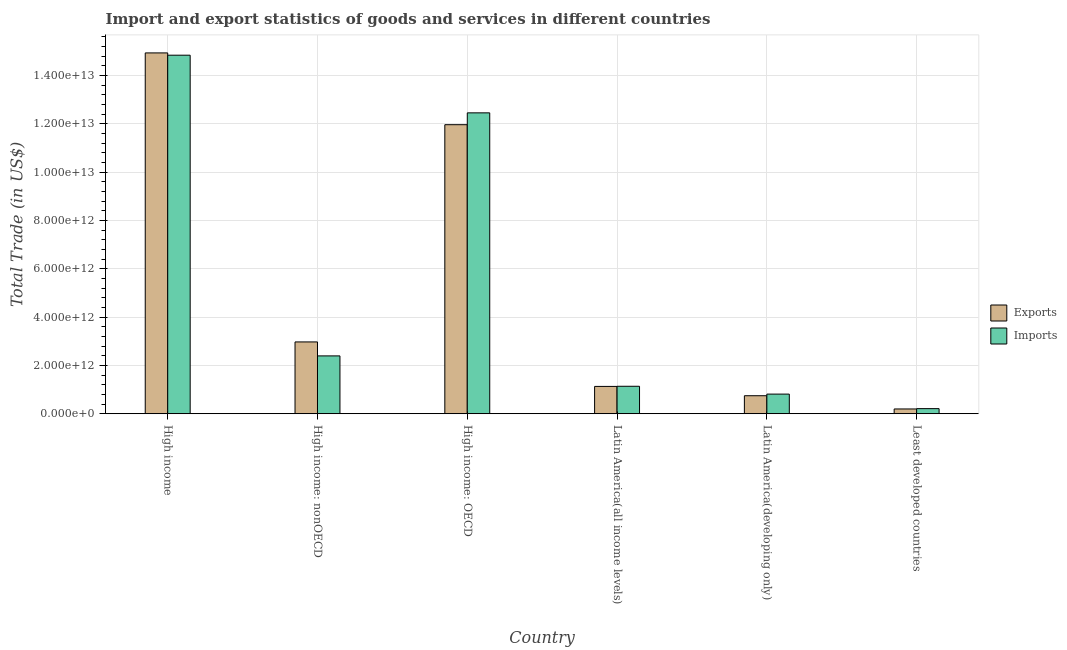How many different coloured bars are there?
Ensure brevity in your answer.  2. Are the number of bars on each tick of the X-axis equal?
Provide a short and direct response. Yes. What is the label of the 4th group of bars from the left?
Offer a terse response. Latin America(all income levels). What is the imports of goods and services in Least developed countries?
Ensure brevity in your answer.  2.12e+11. Across all countries, what is the maximum imports of goods and services?
Provide a short and direct response. 1.48e+13. Across all countries, what is the minimum imports of goods and services?
Keep it short and to the point. 2.12e+11. In which country was the export of goods and services maximum?
Ensure brevity in your answer.  High income. In which country was the imports of goods and services minimum?
Offer a terse response. Least developed countries. What is the total export of goods and services in the graph?
Your answer should be very brief. 3.20e+13. What is the difference between the imports of goods and services in High income: OECD and that in Least developed countries?
Your answer should be compact. 1.22e+13. What is the difference between the export of goods and services in Latin America(all income levels) and the imports of goods and services in Least developed countries?
Offer a very short reply. 9.20e+11. What is the average export of goods and services per country?
Ensure brevity in your answer.  5.33e+12. What is the difference between the imports of goods and services and export of goods and services in Latin America(developing only)?
Make the answer very short. 6.69e+1. In how many countries, is the export of goods and services greater than 6400000000000 US$?
Ensure brevity in your answer.  2. What is the ratio of the export of goods and services in Latin America(all income levels) to that in Least developed countries?
Ensure brevity in your answer.  5.73. Is the imports of goods and services in High income: nonOECD less than that in Latin America(all income levels)?
Ensure brevity in your answer.  No. What is the difference between the highest and the second highest export of goods and services?
Your response must be concise. 2.97e+12. What is the difference between the highest and the lowest imports of goods and services?
Offer a very short reply. 1.46e+13. Is the sum of the export of goods and services in High income and High income: OECD greater than the maximum imports of goods and services across all countries?
Give a very brief answer. Yes. What does the 1st bar from the left in High income represents?
Offer a very short reply. Exports. What does the 1st bar from the right in High income: nonOECD represents?
Ensure brevity in your answer.  Imports. Are all the bars in the graph horizontal?
Your response must be concise. No. How many countries are there in the graph?
Make the answer very short. 6. What is the difference between two consecutive major ticks on the Y-axis?
Offer a terse response. 2.00e+12. Are the values on the major ticks of Y-axis written in scientific E-notation?
Your answer should be very brief. Yes. Does the graph contain grids?
Keep it short and to the point. Yes. How many legend labels are there?
Your answer should be compact. 2. How are the legend labels stacked?
Ensure brevity in your answer.  Vertical. What is the title of the graph?
Offer a very short reply. Import and export statistics of goods and services in different countries. What is the label or title of the X-axis?
Your answer should be very brief. Country. What is the label or title of the Y-axis?
Ensure brevity in your answer.  Total Trade (in US$). What is the Total Trade (in US$) in Exports in High income?
Offer a terse response. 1.49e+13. What is the Total Trade (in US$) of Imports in High income?
Provide a short and direct response. 1.48e+13. What is the Total Trade (in US$) of Exports in High income: nonOECD?
Offer a terse response. 2.97e+12. What is the Total Trade (in US$) of Imports in High income: nonOECD?
Your answer should be compact. 2.39e+12. What is the Total Trade (in US$) of Exports in High income: OECD?
Your answer should be very brief. 1.20e+13. What is the Total Trade (in US$) in Imports in High income: OECD?
Offer a very short reply. 1.25e+13. What is the Total Trade (in US$) in Exports in Latin America(all income levels)?
Offer a very short reply. 1.13e+12. What is the Total Trade (in US$) in Imports in Latin America(all income levels)?
Your answer should be compact. 1.14e+12. What is the Total Trade (in US$) of Exports in Latin America(developing only)?
Ensure brevity in your answer.  7.46e+11. What is the Total Trade (in US$) in Imports in Latin America(developing only)?
Your answer should be compact. 8.13e+11. What is the Total Trade (in US$) in Exports in Least developed countries?
Your answer should be compact. 1.98e+11. What is the Total Trade (in US$) in Imports in Least developed countries?
Ensure brevity in your answer.  2.12e+11. Across all countries, what is the maximum Total Trade (in US$) in Exports?
Offer a terse response. 1.49e+13. Across all countries, what is the maximum Total Trade (in US$) in Imports?
Make the answer very short. 1.48e+13. Across all countries, what is the minimum Total Trade (in US$) in Exports?
Offer a terse response. 1.98e+11. Across all countries, what is the minimum Total Trade (in US$) in Imports?
Your answer should be compact. 2.12e+11. What is the total Total Trade (in US$) in Exports in the graph?
Keep it short and to the point. 3.20e+13. What is the total Total Trade (in US$) of Imports in the graph?
Ensure brevity in your answer.  3.19e+13. What is the difference between the Total Trade (in US$) in Exports in High income and that in High income: nonOECD?
Your answer should be compact. 1.20e+13. What is the difference between the Total Trade (in US$) of Imports in High income and that in High income: nonOECD?
Provide a succinct answer. 1.25e+13. What is the difference between the Total Trade (in US$) in Exports in High income and that in High income: OECD?
Ensure brevity in your answer.  2.97e+12. What is the difference between the Total Trade (in US$) in Imports in High income and that in High income: OECD?
Keep it short and to the point. 2.39e+12. What is the difference between the Total Trade (in US$) of Exports in High income and that in Latin America(all income levels)?
Give a very brief answer. 1.38e+13. What is the difference between the Total Trade (in US$) in Imports in High income and that in Latin America(all income levels)?
Offer a terse response. 1.37e+13. What is the difference between the Total Trade (in US$) in Exports in High income and that in Latin America(developing only)?
Offer a terse response. 1.42e+13. What is the difference between the Total Trade (in US$) in Imports in High income and that in Latin America(developing only)?
Your answer should be very brief. 1.40e+13. What is the difference between the Total Trade (in US$) of Exports in High income and that in Least developed countries?
Your answer should be very brief. 1.47e+13. What is the difference between the Total Trade (in US$) in Imports in High income and that in Least developed countries?
Offer a very short reply. 1.46e+13. What is the difference between the Total Trade (in US$) of Exports in High income: nonOECD and that in High income: OECD?
Provide a succinct answer. -9.00e+12. What is the difference between the Total Trade (in US$) of Imports in High income: nonOECD and that in High income: OECD?
Give a very brief answer. -1.01e+13. What is the difference between the Total Trade (in US$) of Exports in High income: nonOECD and that in Latin America(all income levels)?
Offer a terse response. 1.84e+12. What is the difference between the Total Trade (in US$) of Imports in High income: nonOECD and that in Latin America(all income levels)?
Your response must be concise. 1.26e+12. What is the difference between the Total Trade (in US$) in Exports in High income: nonOECD and that in Latin America(developing only)?
Ensure brevity in your answer.  2.23e+12. What is the difference between the Total Trade (in US$) in Imports in High income: nonOECD and that in Latin America(developing only)?
Your response must be concise. 1.58e+12. What is the difference between the Total Trade (in US$) of Exports in High income: nonOECD and that in Least developed countries?
Offer a very short reply. 2.78e+12. What is the difference between the Total Trade (in US$) in Imports in High income: nonOECD and that in Least developed countries?
Provide a short and direct response. 2.18e+12. What is the difference between the Total Trade (in US$) of Exports in High income: OECD and that in Latin America(all income levels)?
Give a very brief answer. 1.08e+13. What is the difference between the Total Trade (in US$) in Imports in High income: OECD and that in Latin America(all income levels)?
Provide a short and direct response. 1.13e+13. What is the difference between the Total Trade (in US$) in Exports in High income: OECD and that in Latin America(developing only)?
Make the answer very short. 1.12e+13. What is the difference between the Total Trade (in US$) in Imports in High income: OECD and that in Latin America(developing only)?
Offer a terse response. 1.16e+13. What is the difference between the Total Trade (in US$) in Exports in High income: OECD and that in Least developed countries?
Keep it short and to the point. 1.18e+13. What is the difference between the Total Trade (in US$) of Imports in High income: OECD and that in Least developed countries?
Offer a very short reply. 1.22e+13. What is the difference between the Total Trade (in US$) in Exports in Latin America(all income levels) and that in Latin America(developing only)?
Your answer should be very brief. 3.85e+11. What is the difference between the Total Trade (in US$) of Imports in Latin America(all income levels) and that in Latin America(developing only)?
Offer a terse response. 3.24e+11. What is the difference between the Total Trade (in US$) of Exports in Latin America(all income levels) and that in Least developed countries?
Provide a succinct answer. 9.34e+11. What is the difference between the Total Trade (in US$) in Imports in Latin America(all income levels) and that in Least developed countries?
Your answer should be compact. 9.25e+11. What is the difference between the Total Trade (in US$) of Exports in Latin America(developing only) and that in Least developed countries?
Provide a short and direct response. 5.48e+11. What is the difference between the Total Trade (in US$) of Imports in Latin America(developing only) and that in Least developed countries?
Keep it short and to the point. 6.01e+11. What is the difference between the Total Trade (in US$) in Exports in High income and the Total Trade (in US$) in Imports in High income: nonOECD?
Provide a succinct answer. 1.25e+13. What is the difference between the Total Trade (in US$) of Exports in High income and the Total Trade (in US$) of Imports in High income: OECD?
Offer a terse response. 2.48e+12. What is the difference between the Total Trade (in US$) of Exports in High income and the Total Trade (in US$) of Imports in Latin America(all income levels)?
Your response must be concise. 1.38e+13. What is the difference between the Total Trade (in US$) in Exports in High income and the Total Trade (in US$) in Imports in Latin America(developing only)?
Your response must be concise. 1.41e+13. What is the difference between the Total Trade (in US$) of Exports in High income and the Total Trade (in US$) of Imports in Least developed countries?
Give a very brief answer. 1.47e+13. What is the difference between the Total Trade (in US$) in Exports in High income: nonOECD and the Total Trade (in US$) in Imports in High income: OECD?
Your answer should be compact. -9.49e+12. What is the difference between the Total Trade (in US$) in Exports in High income: nonOECD and the Total Trade (in US$) in Imports in Latin America(all income levels)?
Your response must be concise. 1.84e+12. What is the difference between the Total Trade (in US$) of Exports in High income: nonOECD and the Total Trade (in US$) of Imports in Latin America(developing only)?
Give a very brief answer. 2.16e+12. What is the difference between the Total Trade (in US$) in Exports in High income: nonOECD and the Total Trade (in US$) in Imports in Least developed countries?
Offer a very short reply. 2.76e+12. What is the difference between the Total Trade (in US$) in Exports in High income: OECD and the Total Trade (in US$) in Imports in Latin America(all income levels)?
Offer a very short reply. 1.08e+13. What is the difference between the Total Trade (in US$) in Exports in High income: OECD and the Total Trade (in US$) in Imports in Latin America(developing only)?
Provide a succinct answer. 1.12e+13. What is the difference between the Total Trade (in US$) of Exports in High income: OECD and the Total Trade (in US$) of Imports in Least developed countries?
Your answer should be compact. 1.18e+13. What is the difference between the Total Trade (in US$) in Exports in Latin America(all income levels) and the Total Trade (in US$) in Imports in Latin America(developing only)?
Your answer should be very brief. 3.19e+11. What is the difference between the Total Trade (in US$) in Exports in Latin America(all income levels) and the Total Trade (in US$) in Imports in Least developed countries?
Offer a very short reply. 9.20e+11. What is the difference between the Total Trade (in US$) in Exports in Latin America(developing only) and the Total Trade (in US$) in Imports in Least developed countries?
Your response must be concise. 5.34e+11. What is the average Total Trade (in US$) of Exports per country?
Give a very brief answer. 5.33e+12. What is the average Total Trade (in US$) in Imports per country?
Offer a very short reply. 5.31e+12. What is the difference between the Total Trade (in US$) in Exports and Total Trade (in US$) in Imports in High income?
Provide a short and direct response. 9.43e+1. What is the difference between the Total Trade (in US$) of Exports and Total Trade (in US$) of Imports in High income: nonOECD?
Make the answer very short. 5.79e+11. What is the difference between the Total Trade (in US$) in Exports and Total Trade (in US$) in Imports in High income: OECD?
Offer a very short reply. -4.91e+11. What is the difference between the Total Trade (in US$) in Exports and Total Trade (in US$) in Imports in Latin America(all income levels)?
Provide a succinct answer. -5.51e+09. What is the difference between the Total Trade (in US$) of Exports and Total Trade (in US$) of Imports in Latin America(developing only)?
Keep it short and to the point. -6.69e+1. What is the difference between the Total Trade (in US$) in Exports and Total Trade (in US$) in Imports in Least developed countries?
Ensure brevity in your answer.  -1.40e+1. What is the ratio of the Total Trade (in US$) in Exports in High income to that in High income: nonOECD?
Give a very brief answer. 5.03. What is the ratio of the Total Trade (in US$) of Imports in High income to that in High income: nonOECD?
Offer a very short reply. 6.2. What is the ratio of the Total Trade (in US$) in Exports in High income to that in High income: OECD?
Ensure brevity in your answer.  1.25. What is the ratio of the Total Trade (in US$) in Imports in High income to that in High income: OECD?
Your answer should be compact. 1.19. What is the ratio of the Total Trade (in US$) of Exports in High income to that in Latin America(all income levels)?
Provide a succinct answer. 13.2. What is the ratio of the Total Trade (in US$) in Imports in High income to that in Latin America(all income levels)?
Give a very brief answer. 13.06. What is the ratio of the Total Trade (in US$) in Exports in High income to that in Latin America(developing only)?
Your response must be concise. 20.03. What is the ratio of the Total Trade (in US$) in Imports in High income to that in Latin America(developing only)?
Your answer should be very brief. 18.26. What is the ratio of the Total Trade (in US$) in Exports in High income to that in Least developed countries?
Offer a very short reply. 75.63. What is the ratio of the Total Trade (in US$) of Imports in High income to that in Least developed countries?
Offer a very short reply. 70.17. What is the ratio of the Total Trade (in US$) of Exports in High income: nonOECD to that in High income: OECD?
Ensure brevity in your answer.  0.25. What is the ratio of the Total Trade (in US$) in Imports in High income: nonOECD to that in High income: OECD?
Offer a terse response. 0.19. What is the ratio of the Total Trade (in US$) of Exports in High income: nonOECD to that in Latin America(all income levels)?
Your answer should be compact. 2.63. What is the ratio of the Total Trade (in US$) of Imports in High income: nonOECD to that in Latin America(all income levels)?
Keep it short and to the point. 2.11. What is the ratio of the Total Trade (in US$) in Exports in High income: nonOECD to that in Latin America(developing only)?
Provide a short and direct response. 3.99. What is the ratio of the Total Trade (in US$) of Imports in High income: nonOECD to that in Latin America(developing only)?
Give a very brief answer. 2.95. What is the ratio of the Total Trade (in US$) of Exports in High income: nonOECD to that in Least developed countries?
Offer a terse response. 15.05. What is the ratio of the Total Trade (in US$) of Imports in High income: nonOECD to that in Least developed countries?
Offer a terse response. 11.32. What is the ratio of the Total Trade (in US$) of Exports in High income: OECD to that in Latin America(all income levels)?
Provide a succinct answer. 10.58. What is the ratio of the Total Trade (in US$) of Imports in High income: OECD to that in Latin America(all income levels)?
Keep it short and to the point. 10.96. What is the ratio of the Total Trade (in US$) of Exports in High income: OECD to that in Latin America(developing only)?
Your answer should be very brief. 16.04. What is the ratio of the Total Trade (in US$) of Imports in High income: OECD to that in Latin America(developing only)?
Keep it short and to the point. 15.33. What is the ratio of the Total Trade (in US$) in Exports in High income: OECD to that in Least developed countries?
Provide a succinct answer. 60.58. What is the ratio of the Total Trade (in US$) in Imports in High income: OECD to that in Least developed countries?
Offer a very short reply. 58.88. What is the ratio of the Total Trade (in US$) in Exports in Latin America(all income levels) to that in Latin America(developing only)?
Offer a very short reply. 1.52. What is the ratio of the Total Trade (in US$) of Imports in Latin America(all income levels) to that in Latin America(developing only)?
Provide a short and direct response. 1.4. What is the ratio of the Total Trade (in US$) in Exports in Latin America(all income levels) to that in Least developed countries?
Make the answer very short. 5.73. What is the ratio of the Total Trade (in US$) in Imports in Latin America(all income levels) to that in Least developed countries?
Your answer should be compact. 5.37. What is the ratio of the Total Trade (in US$) of Exports in Latin America(developing only) to that in Least developed countries?
Your answer should be very brief. 3.78. What is the ratio of the Total Trade (in US$) in Imports in Latin America(developing only) to that in Least developed countries?
Provide a short and direct response. 3.84. What is the difference between the highest and the second highest Total Trade (in US$) in Exports?
Provide a short and direct response. 2.97e+12. What is the difference between the highest and the second highest Total Trade (in US$) of Imports?
Your answer should be compact. 2.39e+12. What is the difference between the highest and the lowest Total Trade (in US$) in Exports?
Give a very brief answer. 1.47e+13. What is the difference between the highest and the lowest Total Trade (in US$) in Imports?
Keep it short and to the point. 1.46e+13. 